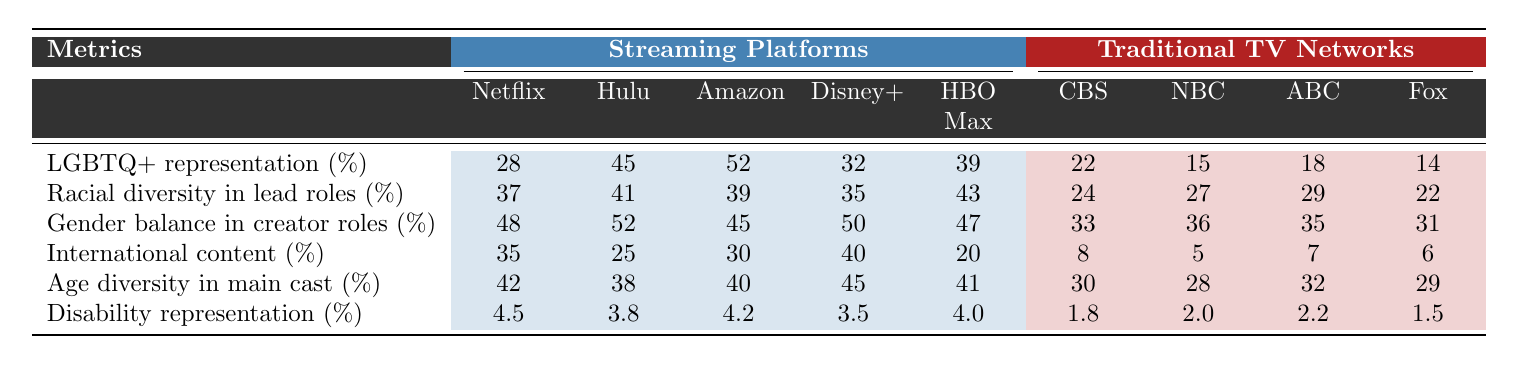What is the LGBTQ+ representation percentage for Amazon Prime Video? The table shows that the LGBTQ+ representation for Amazon Prime Video is 52%.
Answer: 52% Which streaming platform has the highest racial diversity in lead roles? By comparing the values, Netflix has the highest percentage at 37%, while Hulu follows closely with 41%.
Answer: Hulu What is the average gender balance percentage in creator roles across the streaming platforms? The values for gender balance in creator roles for streaming platforms are 48, 52, 45, 50, and 47. Adding them gives a sum of 242, and there are 5 platforms. Therefore, the average is 242/5 = 48.4%.
Answer: 48.4% What percentage of international content does CBS feature? The table indicates that CBS features 8% of international content.
Answer: 8% Does Hulu have higher age diversity in the main cast compared to NBC? Looking at the table, Hulu has an age diversity percentage of 38%, while NBC has 28%. Thus, Hulu does have higher age diversity than NBC.
Answer: Yes What is the difference in disability representation between Disney+ and Fox? Disney+ has a disability representation of 3.5%, while Fox has 1.5%. The difference is 3.5 - 1.5 = 2%.
Answer: 2% Which platform has the lowest disability representation percentage? By checking the table, Fox has the lowest disability representation at 1.5%.
Answer: Fox What is the total percentage of LGBTQ+ representation for all streaming platforms combined? The LGBTQ+ representation percentages for the streaming platforms add up to 28 + 45 + 52 + 32 + 39 = 196%.
Answer: 196% Which traditional TV network has the highest gender balance in creator roles? Among the traditional networks, CBS has the highest percentage at 33%.
Answer: CBS If we average the racial diversity percentages for traditional networks, what is the result? The racial diversity percentages for traditional networks are 24, 27, 29, and 22. Adding these gives a total of 102, and dividing by the number of networks (4) gives an average of 102/4 = 25.5%.
Answer: 25.5% 